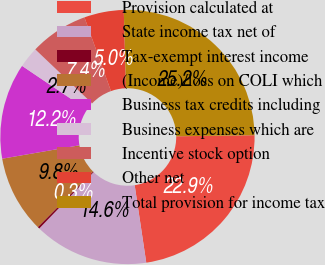Convert chart. <chart><loc_0><loc_0><loc_500><loc_500><pie_chart><fcel>Provision calculated at<fcel>State income tax net of<fcel>Tax-exempt interest income<fcel>(Income)/loss on COLI which<fcel>Business tax credits including<fcel>Business expenses which are<fcel>Incentive stock option<fcel>Other net<fcel>Total provision for income tax<nl><fcel>22.86%<fcel>14.57%<fcel>0.26%<fcel>9.8%<fcel>12.18%<fcel>2.65%<fcel>7.41%<fcel>5.03%<fcel>25.24%<nl></chart> 